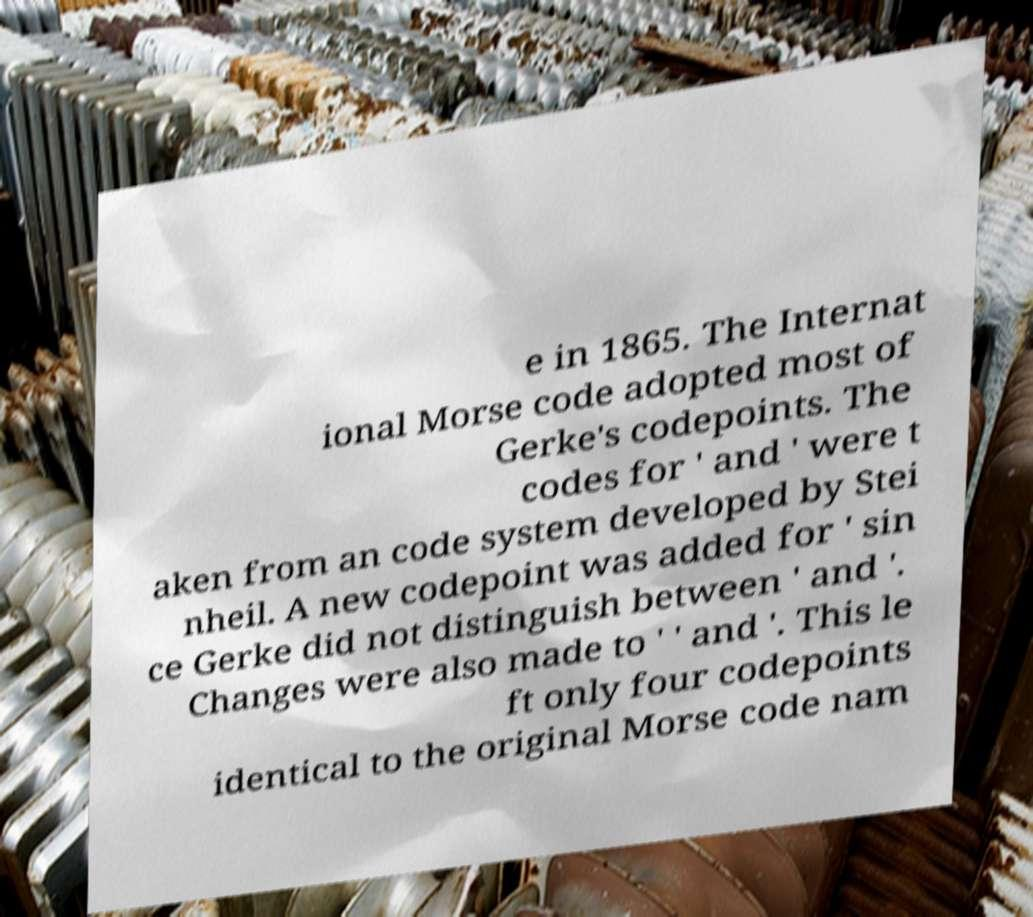What messages or text are displayed in this image? I need them in a readable, typed format. e in 1865. The Internat ional Morse code adopted most of Gerke's codepoints. The codes for ' and ' were t aken from an code system developed by Stei nheil. A new codepoint was added for ' sin ce Gerke did not distinguish between ' and '. Changes were also made to ' ' and '. This le ft only four codepoints identical to the original Morse code nam 